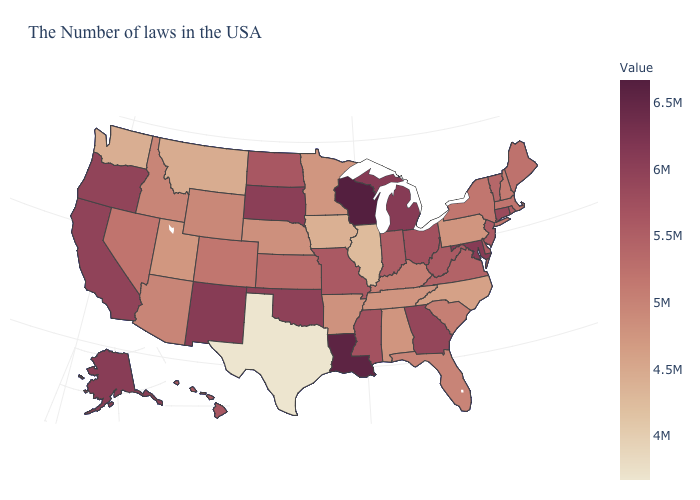Does Louisiana have a lower value than Texas?
Concise answer only. No. Does New Jersey have a higher value than California?
Answer briefly. No. Which states have the lowest value in the MidWest?
Be succinct. Illinois. Which states have the highest value in the USA?
Quick response, please. Wisconsin. 